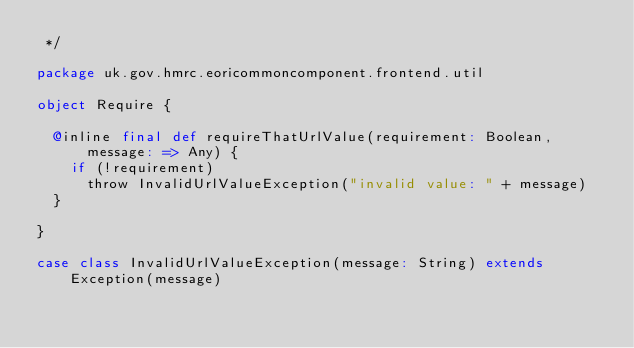Convert code to text. <code><loc_0><loc_0><loc_500><loc_500><_Scala_> */

package uk.gov.hmrc.eoricommoncomponent.frontend.util

object Require {

  @inline final def requireThatUrlValue(requirement: Boolean, message: => Any) {
    if (!requirement)
      throw InvalidUrlValueException("invalid value: " + message)
  }

}

case class InvalidUrlValueException(message: String) extends Exception(message)
</code> 